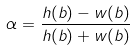Convert formula to latex. <formula><loc_0><loc_0><loc_500><loc_500>\alpha = \frac { h ( b ) - w ( b ) } { h ( b ) + w ( b ) }</formula> 